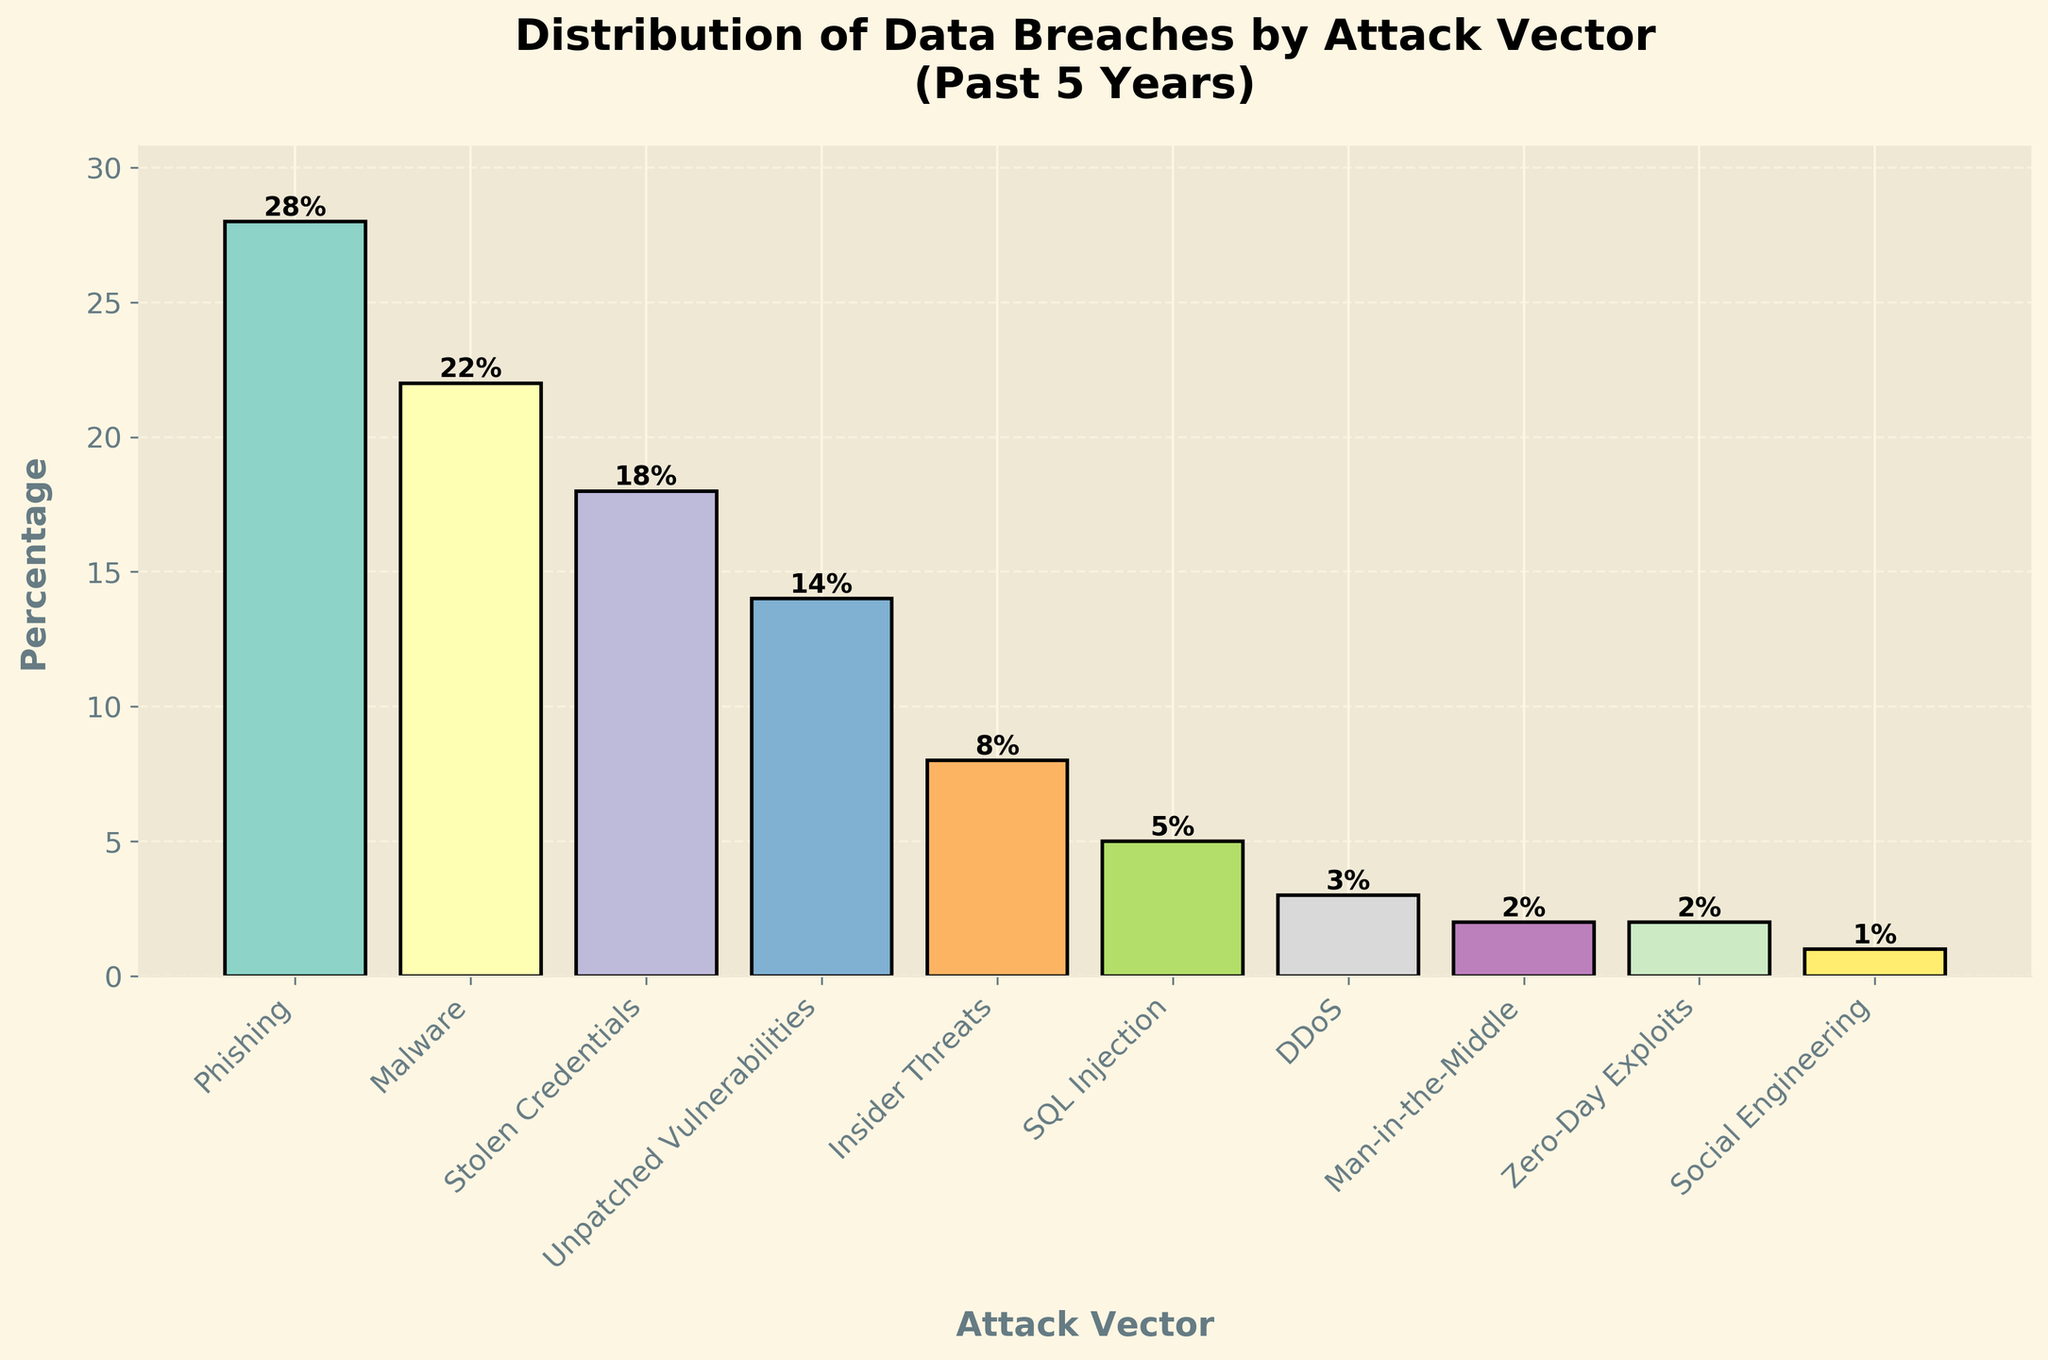What's the total percentage of breaches caused by Phishing, Malware, and Stolen Credentials? To find the total percentage, add the percentages for Phishing (28%), Malware (22%), and Stolen Credentials (18%). So, 28 + 22 + 18 = 68%.
Answer: 68% Which attack vector has the lowest percentage? Look at the bars and identify the shortest one, which represents the smallest percentage. Social Engineering has the shortest bar with a percentage of 1%.
Answer: Social Engineering How much higher is the percentage of breaches due to Phishing compared to Insiders Threats? Calculate the difference between the Phishing percentage (28%) and the Insider Threats percentage (8%). So, 28 - 8 = 20%.
Answer: 20% What is the combined percentage of breaches caused by SQL Injection, DDoS, Man-in-the-Middle, and Zero-Day Exploits? Add the percentages for SQL Injection (5%), DDoS (3%), Man-in-the-Middle (2%), and Zero-Day Exploits (2%). So, 5 + 3 + 2 + 2 = 12%.
Answer: 12% Which attack vectors have a percentage that is equal to or less than 5%? Identify the bars with a height of 5% or less. The attack vectors are SQL Injection (5%), DDoS (3%), Man-in-the-Middle (2%), Zero-Day Exploits (2%), and Social Engineering (1%).
Answer: SQL Injection, DDoS, Man-in-the-Middle, Zero-Day Exploits, Social Engineering Is the percentage of breaches due to Malware higher than the combined percentage of Unpatched Vulnerabilities and Insider Threats? Compare the Malware percentage (22%) with the combined percentage of Unpatched Vulnerabilities (14%) and Insider Threats (8%). Combined, they are 14 + 8 = 22%. They are equal.
Answer: No What is the percentage difference between the highest and the lowest attack vectors? Find the percentages of the highest (Phishing, 28%) and the lowest (Social Engineering, 1%) and calculate the difference. So, 28 - 1 = 27%.
Answer: 27% If you were to create two groups with Attack Vectors causing more than 10% of breaches and those causing 10% or less, what would be the two groups? Group the attack vectors: More than 10%: Phishing (28%), Malware (22%), Stolen Credentials (18%), Unpatched Vulnerabilities (14%). 10% or less: Insider Threats (8%), SQL Injection (5%), DDoS (3%), Man-in-the-Middle (2%), Zero-Day Exploits (2%), Social Engineering (1%).
Answer: More than 10%: Phishing, Malware, Stolen Credentials, Unpatched Vulnerabilities; 10% or less: Insider Threats, SQL Injection, DDoS, Man-in-the-Middle, Zero-Day Exploits, Social Engineering 